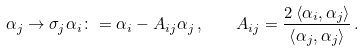<formula> <loc_0><loc_0><loc_500><loc_500>\alpha _ { j } \rightarrow \sigma _ { j } \alpha _ { i } \colon = \alpha _ { i } - A _ { i j } \alpha _ { j } \, , \quad A _ { i j } = \frac { 2 \left \langle \alpha _ { i } , \alpha _ { j } \right \rangle } { \left \langle \alpha _ { j } , \alpha _ { j } \right \rangle } \, .</formula> 